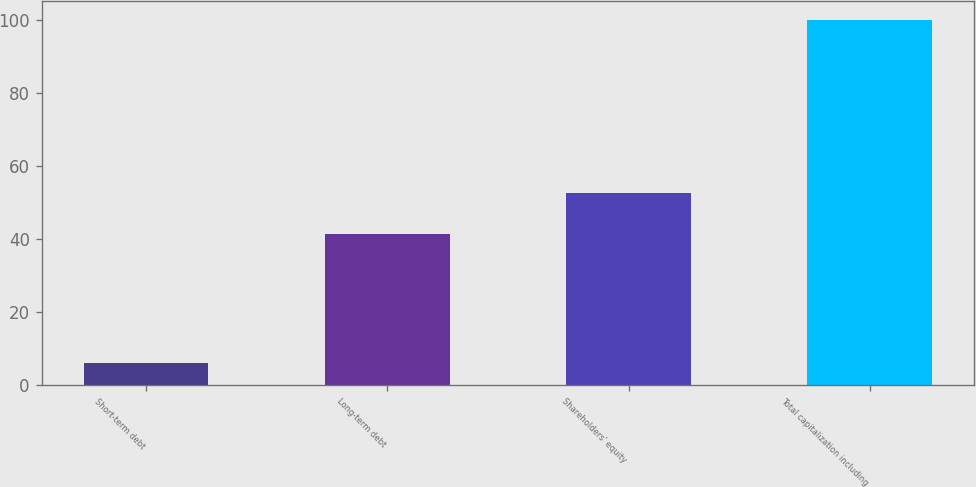Convert chart. <chart><loc_0><loc_0><loc_500><loc_500><bar_chart><fcel>Short-term debt<fcel>Long-term debt<fcel>Shareholders' equity<fcel>Total capitalization including<nl><fcel>6<fcel>41.4<fcel>52.6<fcel>100<nl></chart> 